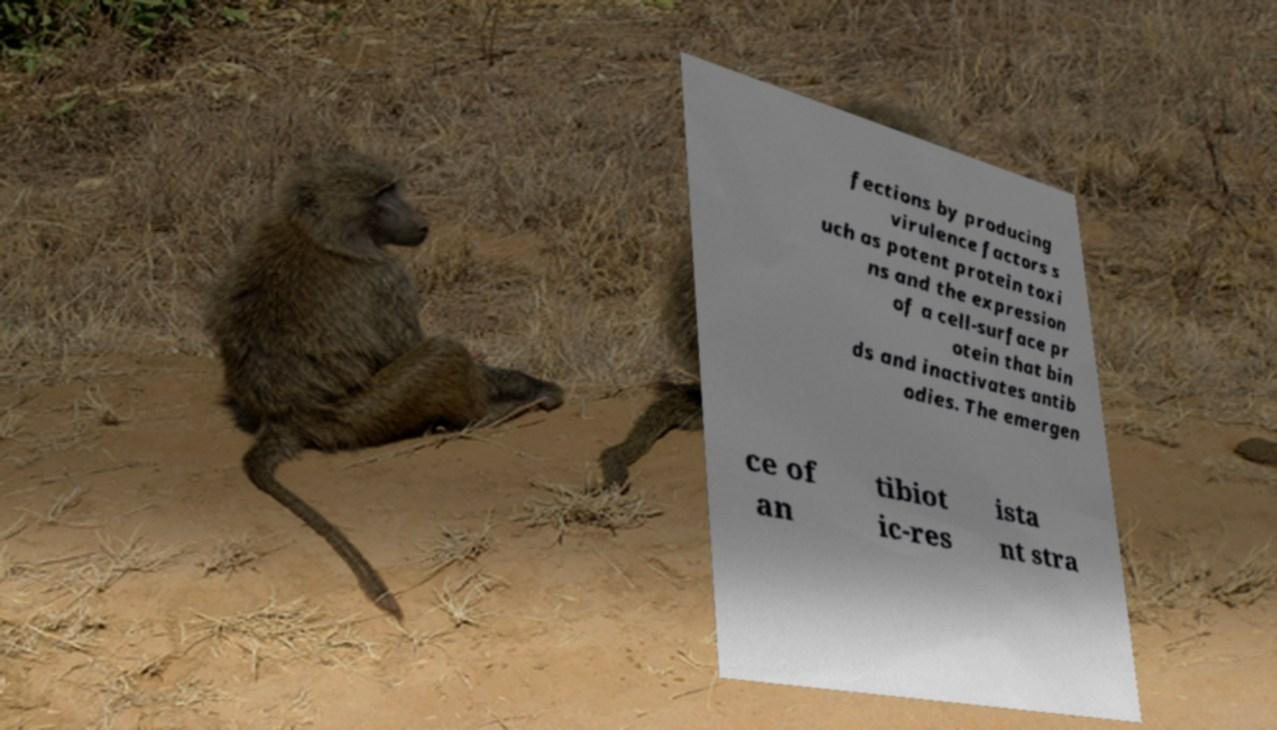I need the written content from this picture converted into text. Can you do that? fections by producing virulence factors s uch as potent protein toxi ns and the expression of a cell-surface pr otein that bin ds and inactivates antib odies. The emergen ce of an tibiot ic-res ista nt stra 